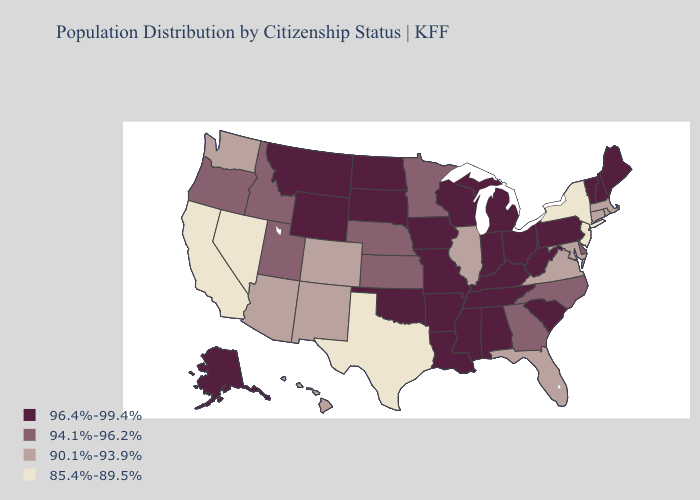Name the states that have a value in the range 96.4%-99.4%?
Concise answer only. Alabama, Alaska, Arkansas, Indiana, Iowa, Kentucky, Louisiana, Maine, Michigan, Mississippi, Missouri, Montana, New Hampshire, North Dakota, Ohio, Oklahoma, Pennsylvania, South Carolina, South Dakota, Tennessee, Vermont, West Virginia, Wisconsin, Wyoming. Name the states that have a value in the range 94.1%-96.2%?
Give a very brief answer. Delaware, Georgia, Idaho, Kansas, Minnesota, Nebraska, North Carolina, Oregon, Utah. Does Rhode Island have a higher value than Washington?
Write a very short answer. No. What is the value of Kansas?
Concise answer only. 94.1%-96.2%. Among the states that border Colorado , does Arizona have the highest value?
Give a very brief answer. No. Does the first symbol in the legend represent the smallest category?
Concise answer only. No. What is the lowest value in the USA?
Short answer required. 85.4%-89.5%. What is the value of Maryland?
Short answer required. 90.1%-93.9%. Name the states that have a value in the range 94.1%-96.2%?
Be succinct. Delaware, Georgia, Idaho, Kansas, Minnesota, Nebraska, North Carolina, Oregon, Utah. What is the value of Louisiana?
Answer briefly. 96.4%-99.4%. What is the value of Kansas?
Quick response, please. 94.1%-96.2%. What is the lowest value in states that border New Jersey?
Keep it brief. 85.4%-89.5%. Which states have the highest value in the USA?
Concise answer only. Alabama, Alaska, Arkansas, Indiana, Iowa, Kentucky, Louisiana, Maine, Michigan, Mississippi, Missouri, Montana, New Hampshire, North Dakota, Ohio, Oklahoma, Pennsylvania, South Carolina, South Dakota, Tennessee, Vermont, West Virginia, Wisconsin, Wyoming. Which states have the highest value in the USA?
Give a very brief answer. Alabama, Alaska, Arkansas, Indiana, Iowa, Kentucky, Louisiana, Maine, Michigan, Mississippi, Missouri, Montana, New Hampshire, North Dakota, Ohio, Oklahoma, Pennsylvania, South Carolina, South Dakota, Tennessee, Vermont, West Virginia, Wisconsin, Wyoming. Name the states that have a value in the range 96.4%-99.4%?
Answer briefly. Alabama, Alaska, Arkansas, Indiana, Iowa, Kentucky, Louisiana, Maine, Michigan, Mississippi, Missouri, Montana, New Hampshire, North Dakota, Ohio, Oklahoma, Pennsylvania, South Carolina, South Dakota, Tennessee, Vermont, West Virginia, Wisconsin, Wyoming. 